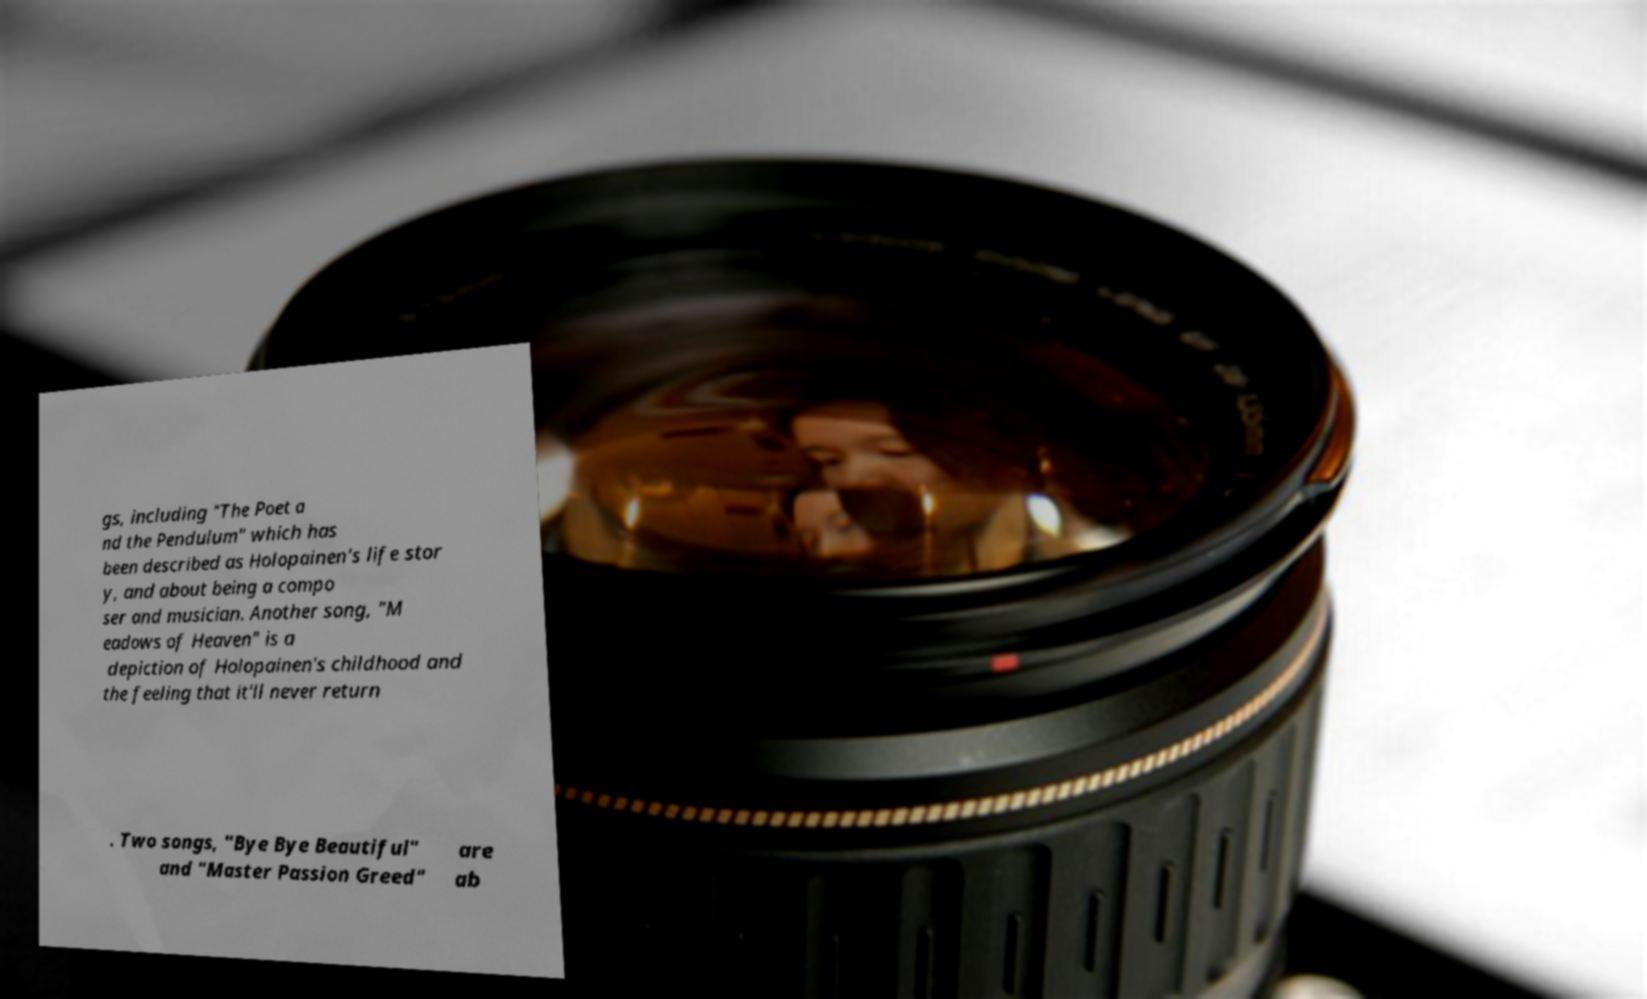What messages or text are displayed in this image? I need them in a readable, typed format. gs, including "The Poet a nd the Pendulum" which has been described as Holopainen's life stor y, and about being a compo ser and musician. Another song, "M eadows of Heaven" is a depiction of Holopainen's childhood and the feeling that it'll never return . Two songs, "Bye Bye Beautiful" and "Master Passion Greed" are ab 